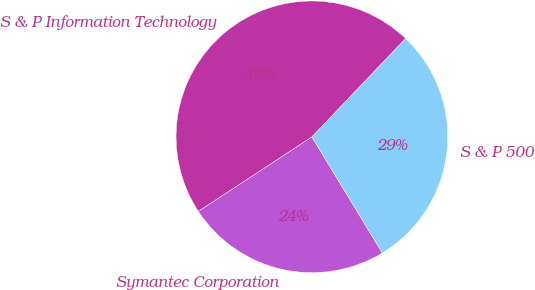Convert chart. <chart><loc_0><loc_0><loc_500><loc_500><pie_chart><fcel>Symantec Corporation<fcel>S & P 500<fcel>S & P Information Technology<nl><fcel>24.44%<fcel>29.21%<fcel>46.35%<nl></chart> 